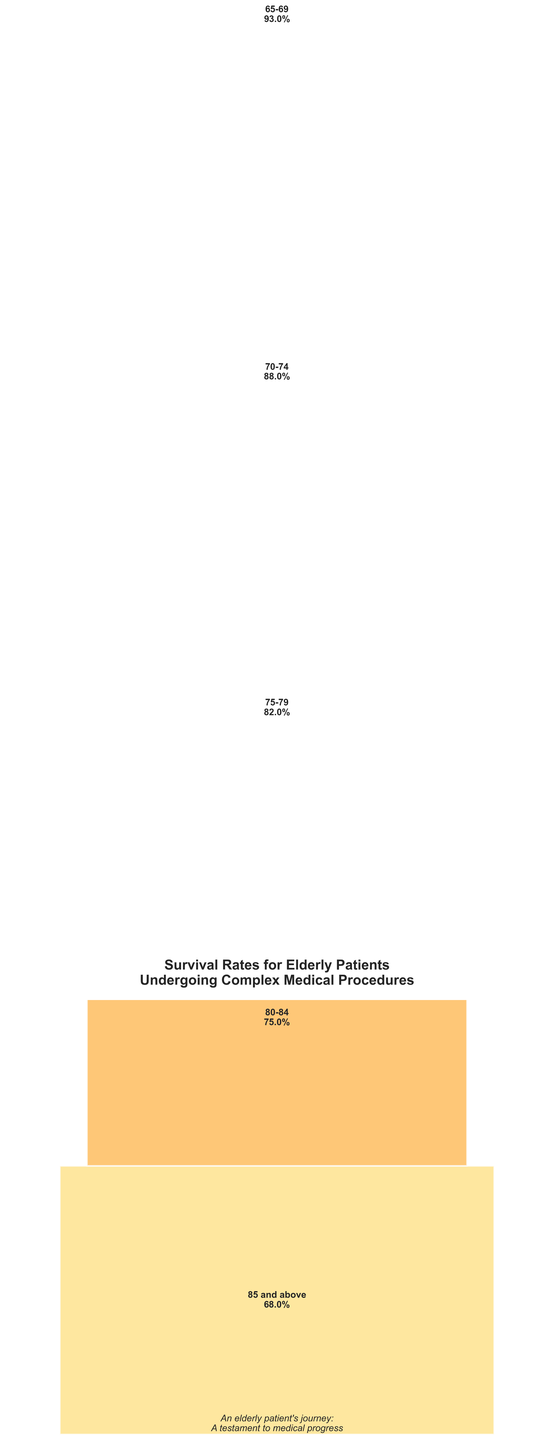What's the title of the figure? The title of the figure is usually placed at the top, and in this case, it reads "Survival Rates for Elderly Patients Undergoing Complex Medical Procedures."
Answer: Survival Rates for Elderly Patients Undergoing Complex Medical Procedures Which age group has the highest survival rate? To determine the highest survival rate, look at the percentage values listed next to each age group. The highest percentage is 93%, which corresponds to the 65-69 age group.
Answer: 65-69 Which age group has the lowest survival rate? Identify the lowest percentage value in the figure. The lowest survival rate is 68%, which corresponds to the 85 and above age group.
Answer: 85 and above What is the survival rate for the 75-79 age group? Locate the bar and text label associated with the 75-79 age group. It shows a survival rate of 82%.
Answer: 82% How many different age groups are shown in the figure? Count the number of distinct age groups listed. There are five different age groups.
Answer: Five What is the overall trend in survival rates as age increases? Observe the pattern of survival rates across the age groups. There is a clear decreasing trend in survival rates as age increases.
Answer: Decreasing How much higher is the survival rate for the 70-74 age group compared to the 80-84 age group? Determine the survival rates for both groups: 88% for 70-74 and 75% for 80-84. Subtract the smaller rate from the larger one: 88% - 75% = 13%.
Answer: 13% What is the average survival rate across all age groups? Add all the survival rates: 68% + 75% + 82% + 88% + 93% = 406%. Then divide by the number of age groups: 406% / 5 = 81.2%.
Answer: 81.2% How much does the survival rate drop from the 70-74 age group to the 85 and above age group? Compare the rates for the 70-74 age group (88%) and the 85 and above age group (68%). The difference is 88% - 68% = 20%.
Answer: 20% Is the survival rate for the 75-79 age group closer to the 70-74 age group or the 80-84 age group? Survival rates: 75-79 (82%), 70-74 (88%), and 80-84 (75%). The difference with 70-74 is 88% - 82% = 6%, and with 80-84 is 82% - 75% = 7%. So, it is closer to the 70-74 age group.
Answer: 70-74age group What is the median survival rate among all the age groups? Arrange survival rates: 68%, 75%, 82%, 88%, 93%. The middle value here, since there are five data points, is 82%, corresponding to the 75-79 age group.
Answer: 82% 